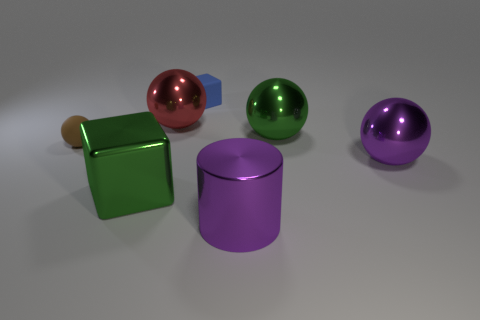Subtract 1 balls. How many balls are left? 3 Add 2 purple metallic cylinders. How many objects exist? 9 Subtract all cylinders. How many objects are left? 6 Subtract all metal balls. Subtract all green shiny balls. How many objects are left? 3 Add 7 big green shiny objects. How many big green shiny objects are left? 9 Add 5 tiny gray rubber cylinders. How many tiny gray rubber cylinders exist? 5 Subtract 0 yellow cylinders. How many objects are left? 7 